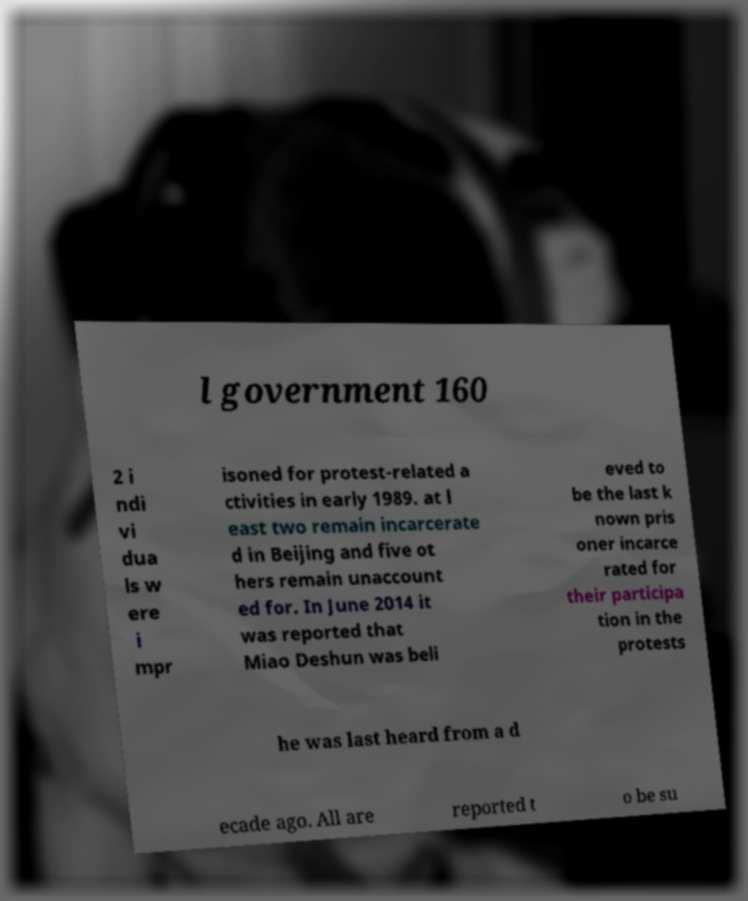Please identify and transcribe the text found in this image. l government 160 2 i ndi vi dua ls w ere i mpr isoned for protest-related a ctivities in early 1989. at l east two remain incarcerate d in Beijing and five ot hers remain unaccount ed for. In June 2014 it was reported that Miao Deshun was beli eved to be the last k nown pris oner incarce rated for their participa tion in the protests he was last heard from a d ecade ago. All are reported t o be su 